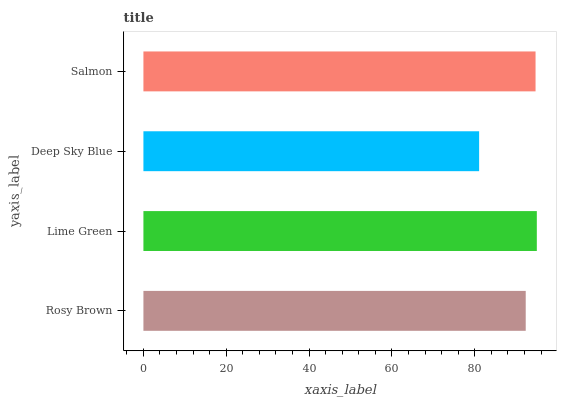Is Deep Sky Blue the minimum?
Answer yes or no. Yes. Is Lime Green the maximum?
Answer yes or no. Yes. Is Lime Green the minimum?
Answer yes or no. No. Is Deep Sky Blue the maximum?
Answer yes or no. No. Is Lime Green greater than Deep Sky Blue?
Answer yes or no. Yes. Is Deep Sky Blue less than Lime Green?
Answer yes or no. Yes. Is Deep Sky Blue greater than Lime Green?
Answer yes or no. No. Is Lime Green less than Deep Sky Blue?
Answer yes or no. No. Is Salmon the high median?
Answer yes or no. Yes. Is Rosy Brown the low median?
Answer yes or no. Yes. Is Rosy Brown the high median?
Answer yes or no. No. Is Deep Sky Blue the low median?
Answer yes or no. No. 